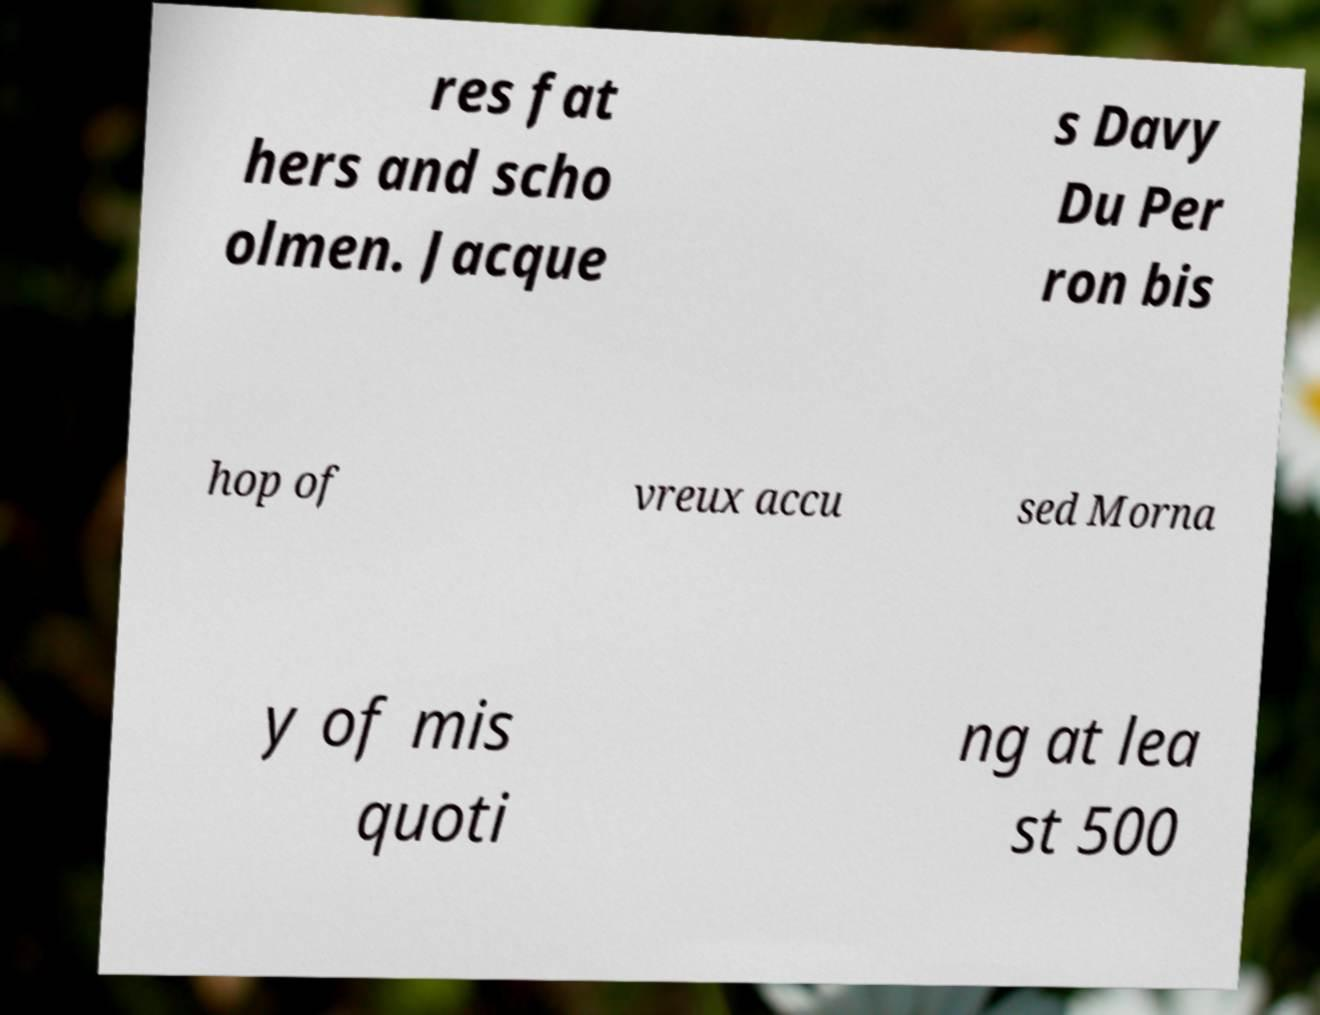There's text embedded in this image that I need extracted. Can you transcribe it verbatim? res fat hers and scho olmen. Jacque s Davy Du Per ron bis hop of vreux accu sed Morna y of mis quoti ng at lea st 500 